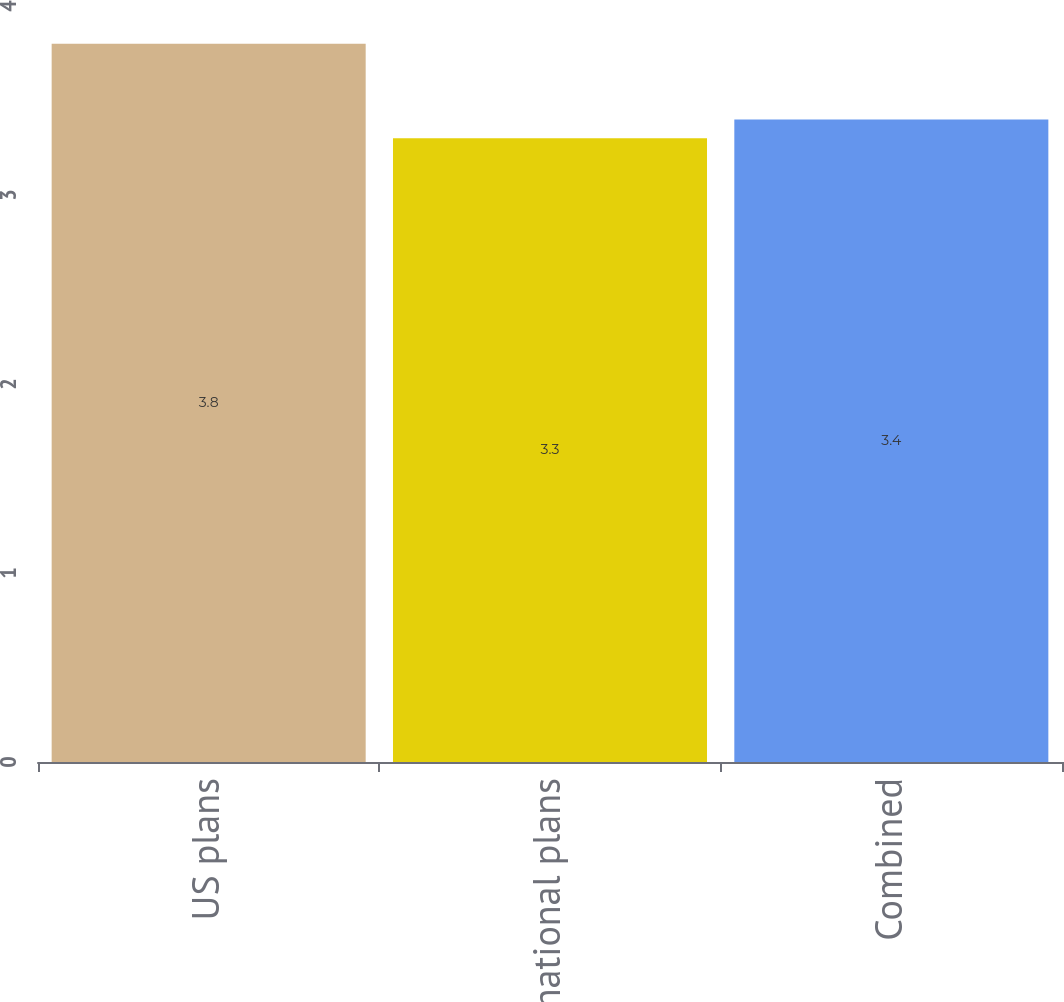Convert chart to OTSL. <chart><loc_0><loc_0><loc_500><loc_500><bar_chart><fcel>US plans<fcel>International plans<fcel>Combined<nl><fcel>3.8<fcel>3.3<fcel>3.4<nl></chart> 